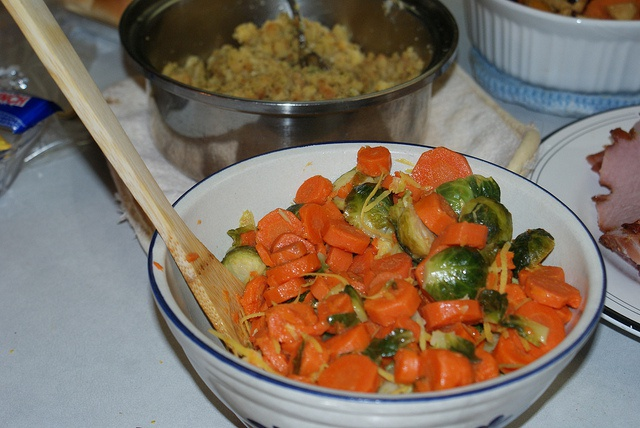Describe the objects in this image and their specific colors. I can see dining table in darkgray, black, gray, brown, and olive tones, bowl in maroon, darkgray, brown, and red tones, bowl in maroon, black, olive, and gray tones, bowl in maroon, darkgray, and gray tones, and spoon in maroon, tan, darkgray, and olive tones in this image. 